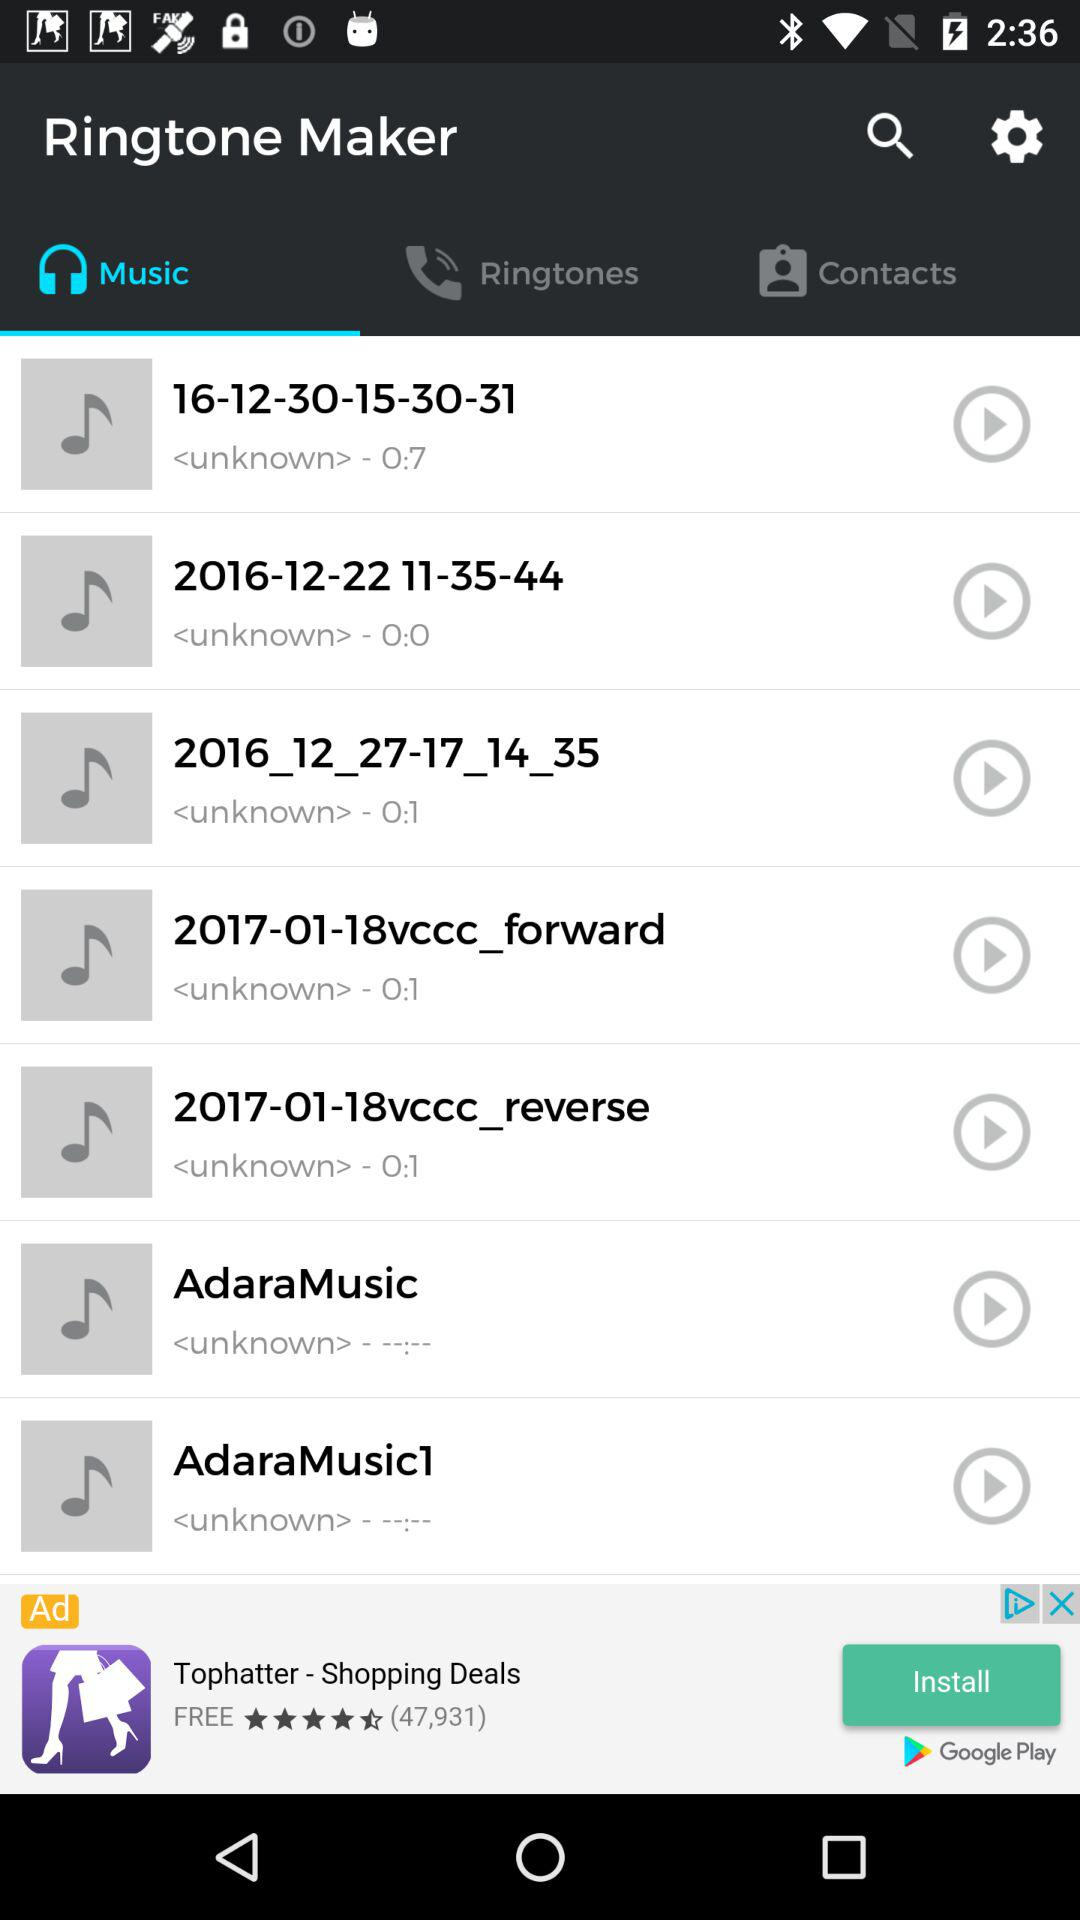What is the time duration of the "18vccc_forward" track? The time duration is 0:1. 